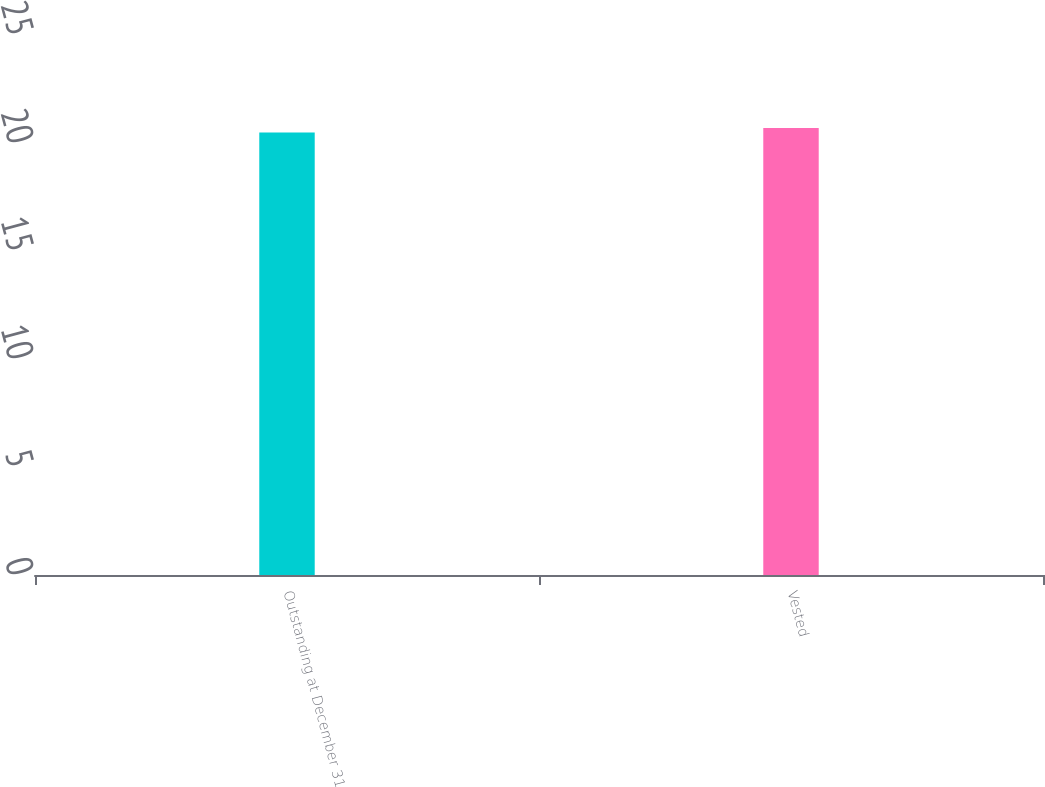Convert chart. <chart><loc_0><loc_0><loc_500><loc_500><bar_chart><fcel>Outstanding at December 31<fcel>Vested<nl><fcel>20.49<fcel>20.69<nl></chart> 